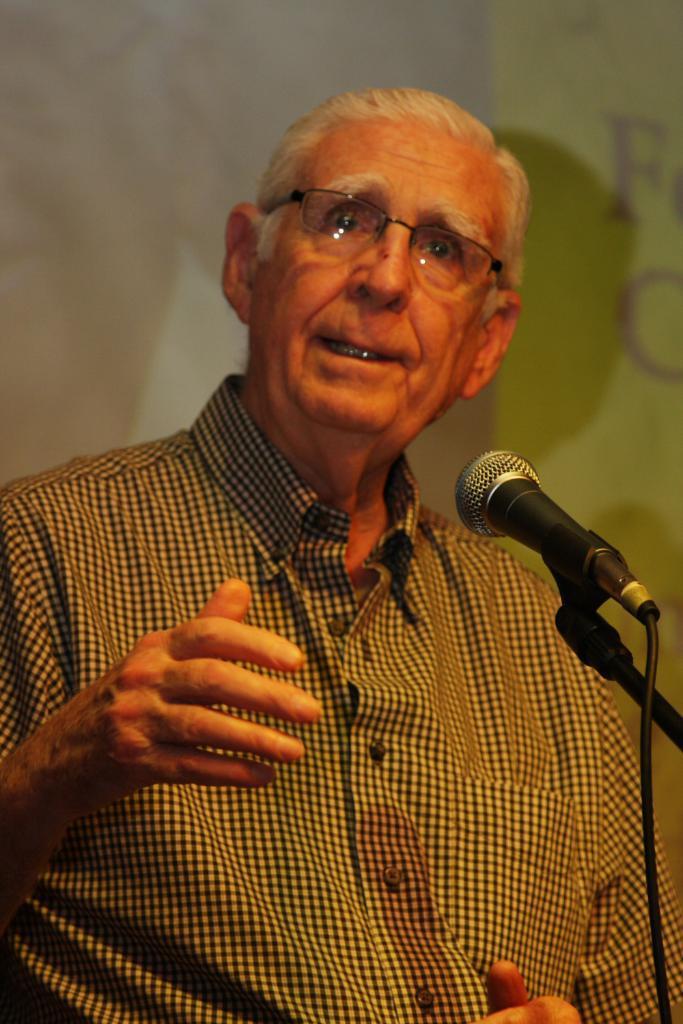In one or two sentences, can you explain what this image depicts? In this image we can see a man wearing specs. In front of him there is a mic with mic stand. In the back there is a wall. 